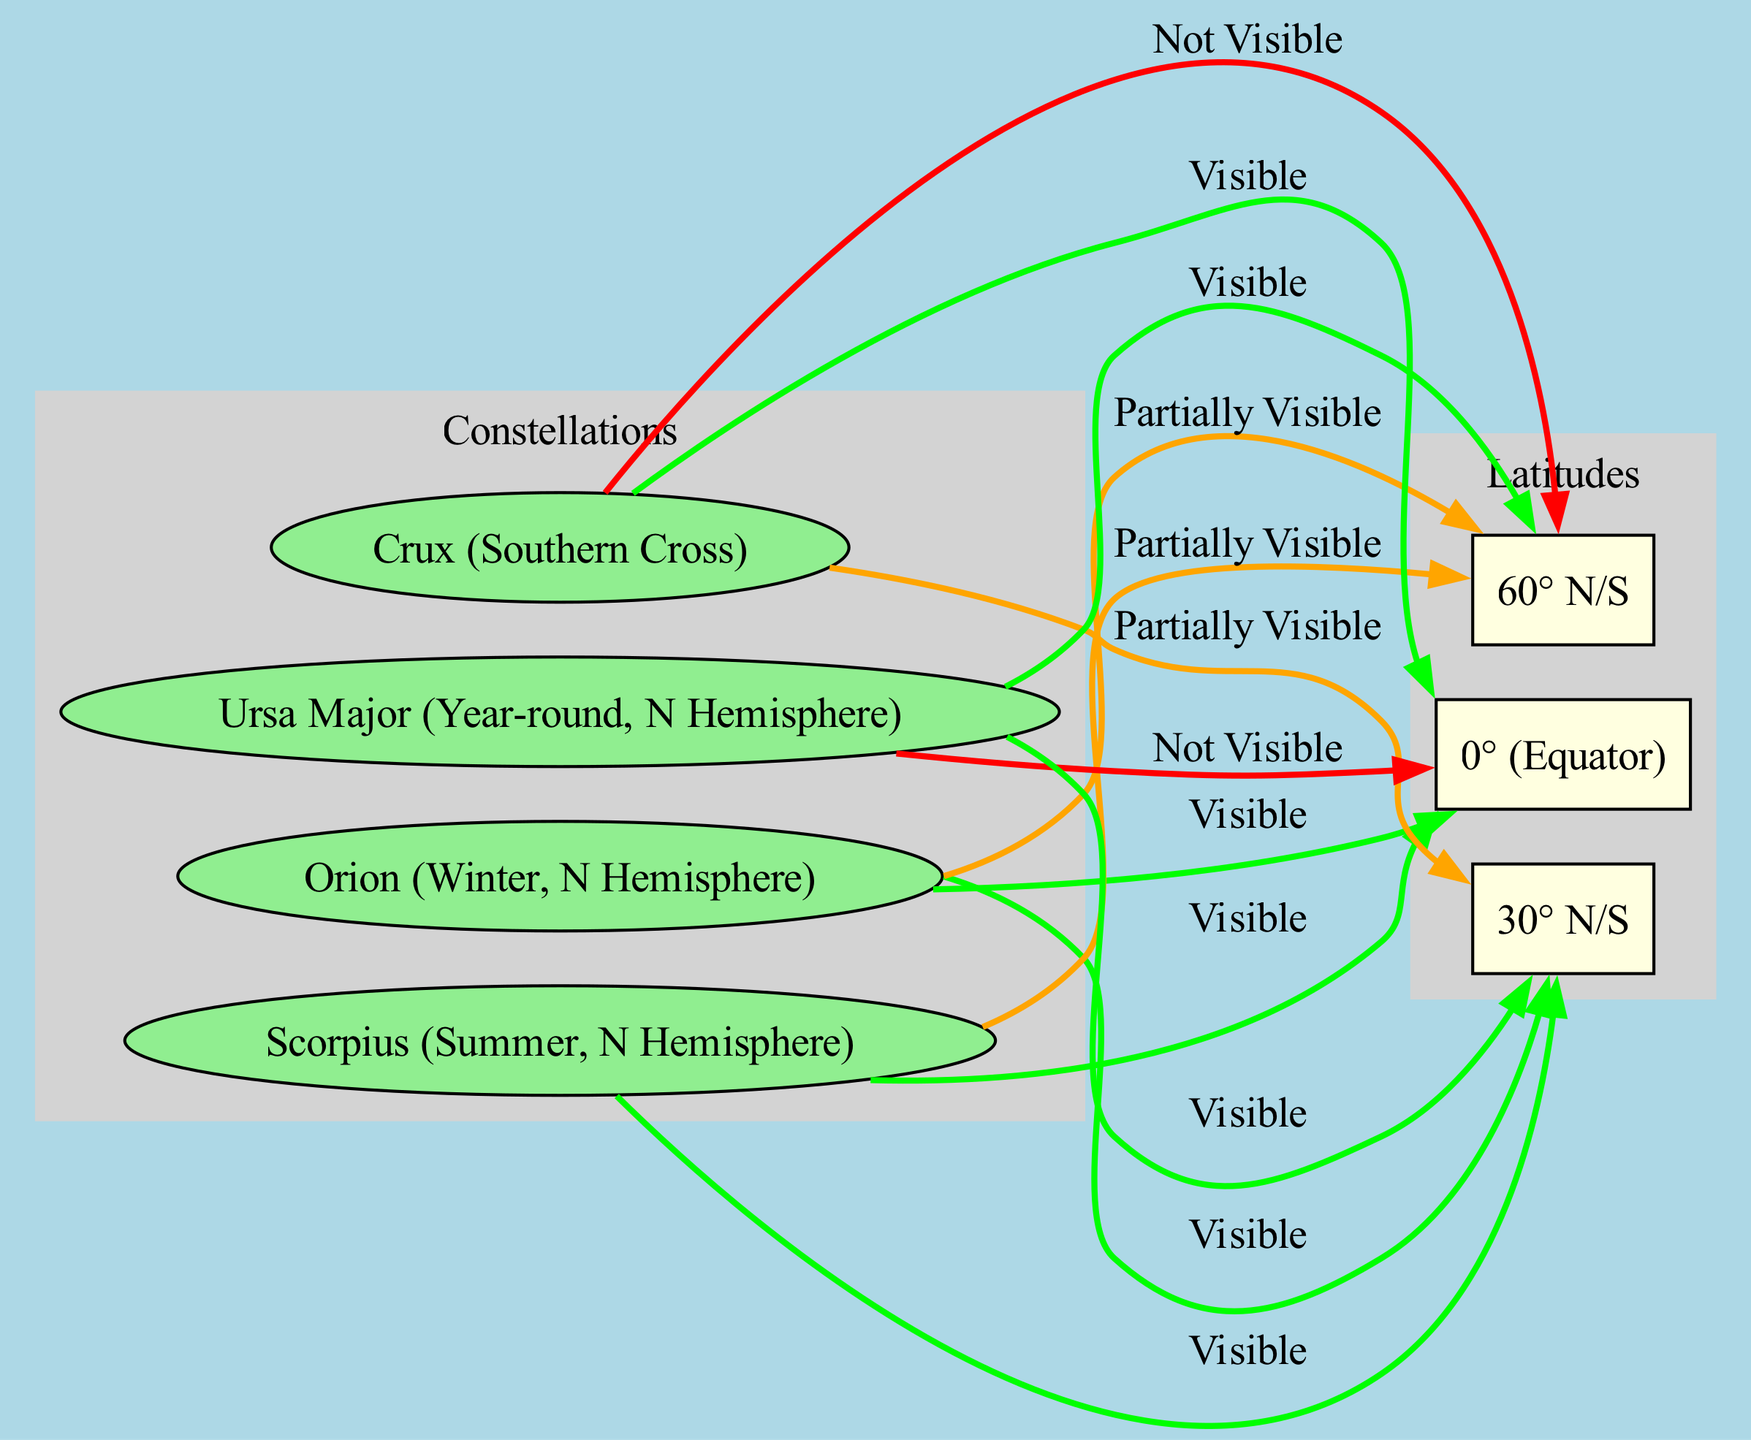What constellations are visible from the Equator? From the diagram, the constellations that have a direct edge labeled "Visible" to the node representing the Equator (0°) are Orion, Scorpius, and Crux.
Answer: Orion, Scorpius, Crux Which constellation is not visible from the Equator? The diagram shows that Ursa Major has a direct edge labeled "Not Visible" from the Equator (0°), indicating it cannot be seen from this latitude.
Answer: Ursa Major How many constellations are partially visible from 60° latitude? The edges show that both Orion and Scorpius are labeled as "Partially Visible" from the 60° latitude, giving us a total of 2 constellations.
Answer: 2 What is the visibility status of Scorpius at 30° latitude? At 30° latitude, the diagram indicates an edge from Scorpius labeled "Visible," meaning it can be seen from this latitude.
Answer: Visible Which constellation is visible year-round in the Northern Hemisphere? According to the diagram, Ursa Major is labeled with "Visible" at both 30° and 60°, meaning it is intricately designed to be visible year-round in the Northern Hemisphere.
Answer: Ursa Major From which latitude is Crux not visible? The diagram shows Crux has a direct edge labeled "Not Visible" leading to the 60° latitude, meaning it cannot be seen from there.
Answer: 60° N/S Which constellations are visible from both 30° and 0° latitudes? Checking the edges for both 30° and 0°, Orion, Scorpius, and Ursa Major are visible from both, as indicated by edges labeled "Visible."
Answer: Orion, Scorpius, Ursa Major What does the color orange represent in the diagram? In this diagram, the orange color represents edges labeled as "Partially Visible," which indicate constellations that can be seen but not fully.
Answer: Partially Visible 